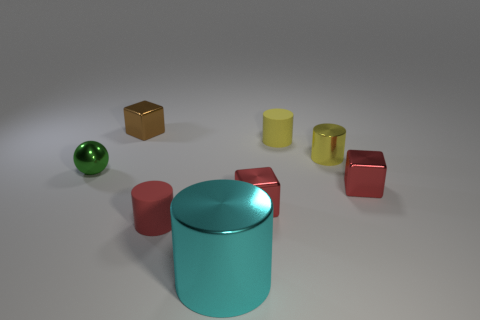If these objects were part of a game, what kind of game could it be? These objects could be part of a matching or sorting game where players are required to organize them according to shape or color. Alternatively, they could be used in a physics-based game where the aim is to stack the objects without them toppling over. 